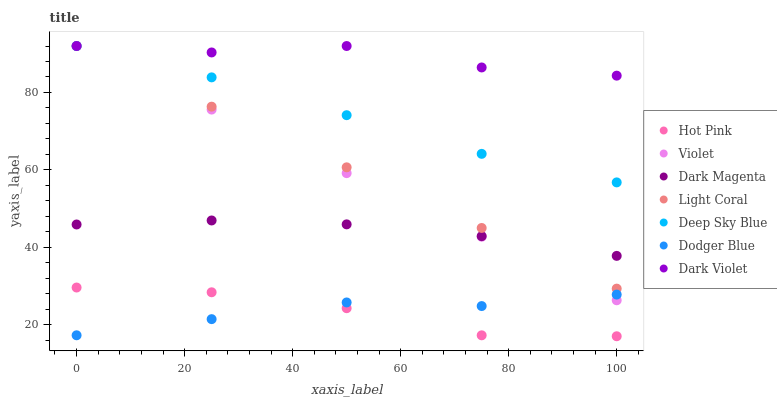Does Hot Pink have the minimum area under the curve?
Answer yes or no. Yes. Does Dark Violet have the maximum area under the curve?
Answer yes or no. Yes. Does Dark Violet have the minimum area under the curve?
Answer yes or no. No. Does Hot Pink have the maximum area under the curve?
Answer yes or no. No. Is Light Coral the smoothest?
Answer yes or no. Yes. Is Dark Violet the roughest?
Answer yes or no. Yes. Is Hot Pink the smoothest?
Answer yes or no. No. Is Hot Pink the roughest?
Answer yes or no. No. Does Hot Pink have the lowest value?
Answer yes or no. Yes. Does Dark Violet have the lowest value?
Answer yes or no. No. Does Violet have the highest value?
Answer yes or no. Yes. Does Hot Pink have the highest value?
Answer yes or no. No. Is Dodger Blue less than Deep Sky Blue?
Answer yes or no. Yes. Is Deep Sky Blue greater than Hot Pink?
Answer yes or no. Yes. Does Dodger Blue intersect Hot Pink?
Answer yes or no. Yes. Is Dodger Blue less than Hot Pink?
Answer yes or no. No. Is Dodger Blue greater than Hot Pink?
Answer yes or no. No. Does Dodger Blue intersect Deep Sky Blue?
Answer yes or no. No. 